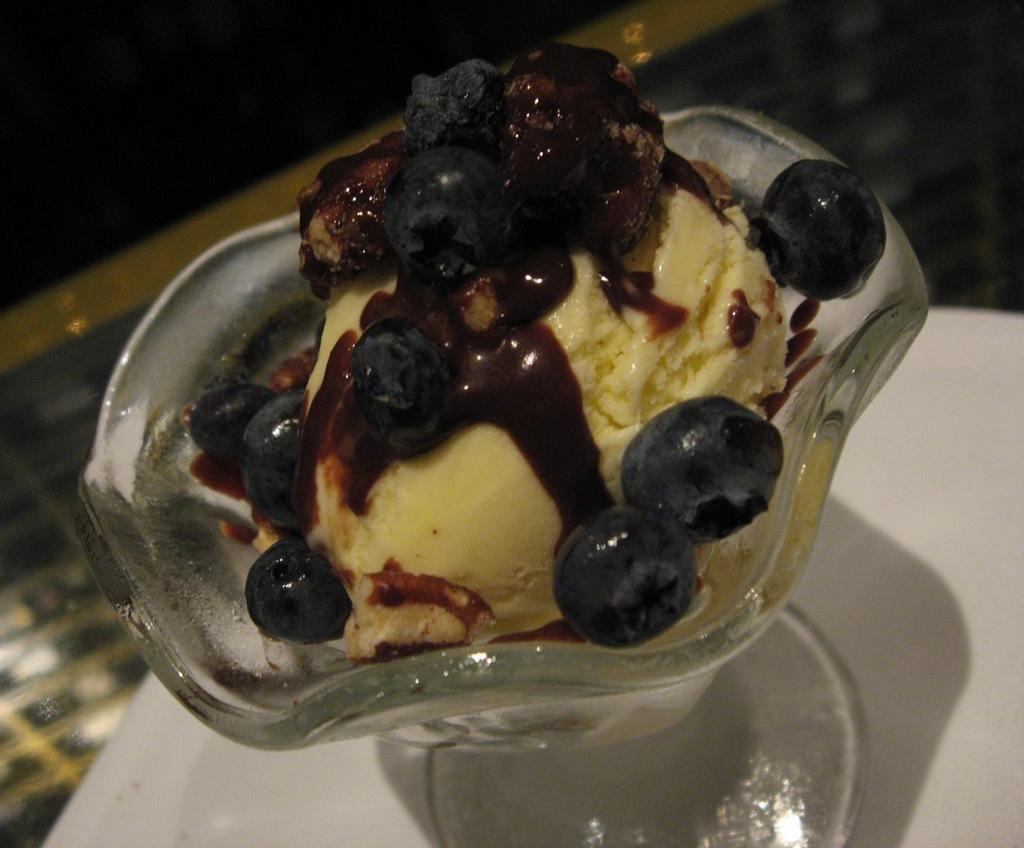Can you describe this image briefly? This image consist of an ice cream which is in the bowl, which is on the surface which is white in colour. 